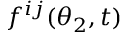Convert formula to latex. <formula><loc_0><loc_0><loc_500><loc_500>f ^ { i j } ( \theta _ { 2 } , t )</formula> 